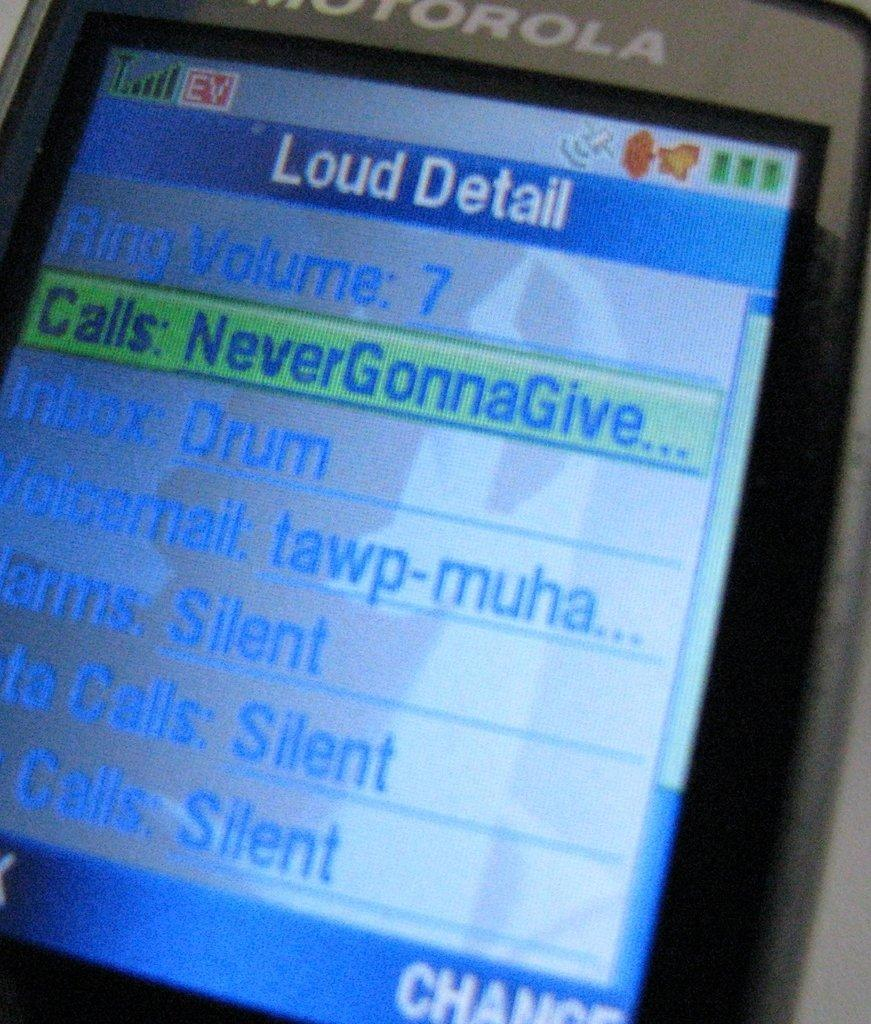<image>
Relay a brief, clear account of the picture shown. A close up of the screen of an old motorola cell phone. 